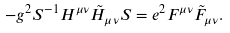Convert formula to latex. <formula><loc_0><loc_0><loc_500><loc_500>- g ^ { 2 } S ^ { - 1 } H ^ { \mu \nu } \tilde { H } _ { \mu \nu } S = e ^ { 2 } F ^ { \mu \nu } \tilde { F } _ { \mu \nu } .</formula> 